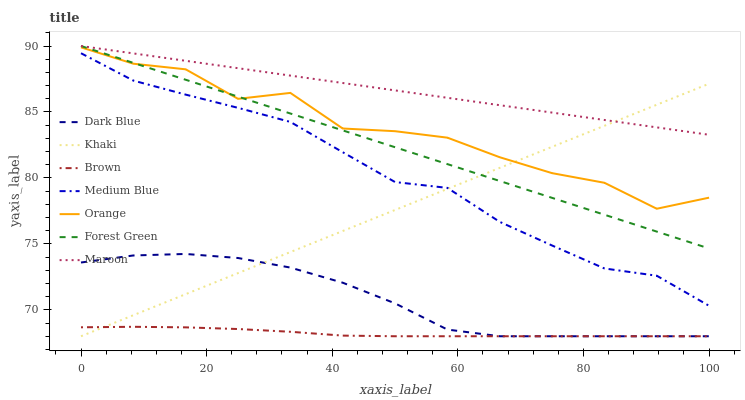Does Brown have the minimum area under the curve?
Answer yes or no. Yes. Does Maroon have the maximum area under the curve?
Answer yes or no. Yes. Does Khaki have the minimum area under the curve?
Answer yes or no. No. Does Khaki have the maximum area under the curve?
Answer yes or no. No. Is Maroon the smoothest?
Answer yes or no. Yes. Is Orange the roughest?
Answer yes or no. Yes. Is Khaki the smoothest?
Answer yes or no. No. Is Khaki the roughest?
Answer yes or no. No. Does Brown have the lowest value?
Answer yes or no. Yes. Does Medium Blue have the lowest value?
Answer yes or no. No. Does Forest Green have the highest value?
Answer yes or no. Yes. Does Khaki have the highest value?
Answer yes or no. No. Is Dark Blue less than Medium Blue?
Answer yes or no. Yes. Is Maroon greater than Orange?
Answer yes or no. Yes. Does Khaki intersect Maroon?
Answer yes or no. Yes. Is Khaki less than Maroon?
Answer yes or no. No. Is Khaki greater than Maroon?
Answer yes or no. No. Does Dark Blue intersect Medium Blue?
Answer yes or no. No. 